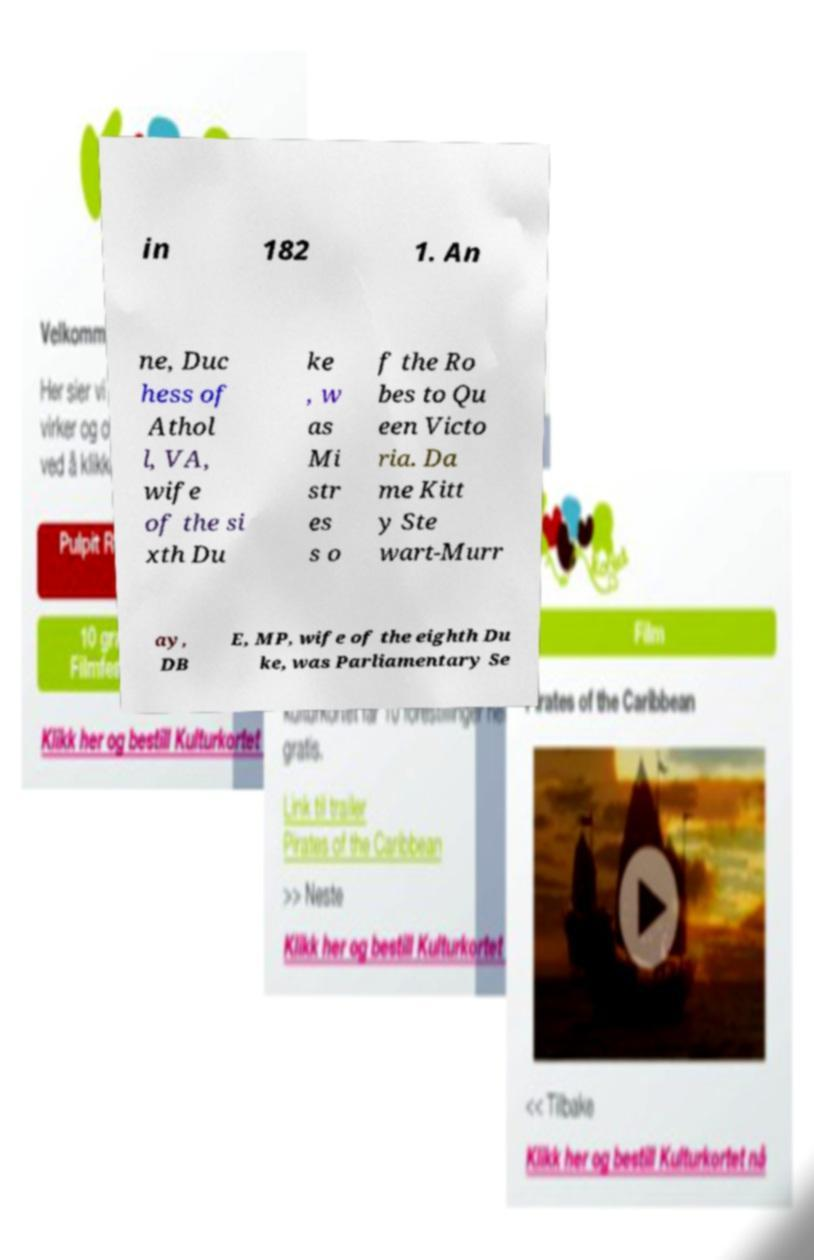There's text embedded in this image that I need extracted. Can you transcribe it verbatim? in 182 1. An ne, Duc hess of Athol l, VA, wife of the si xth Du ke , w as Mi str es s o f the Ro bes to Qu een Victo ria. Da me Kitt y Ste wart-Murr ay, DB E, MP, wife of the eighth Du ke, was Parliamentary Se 